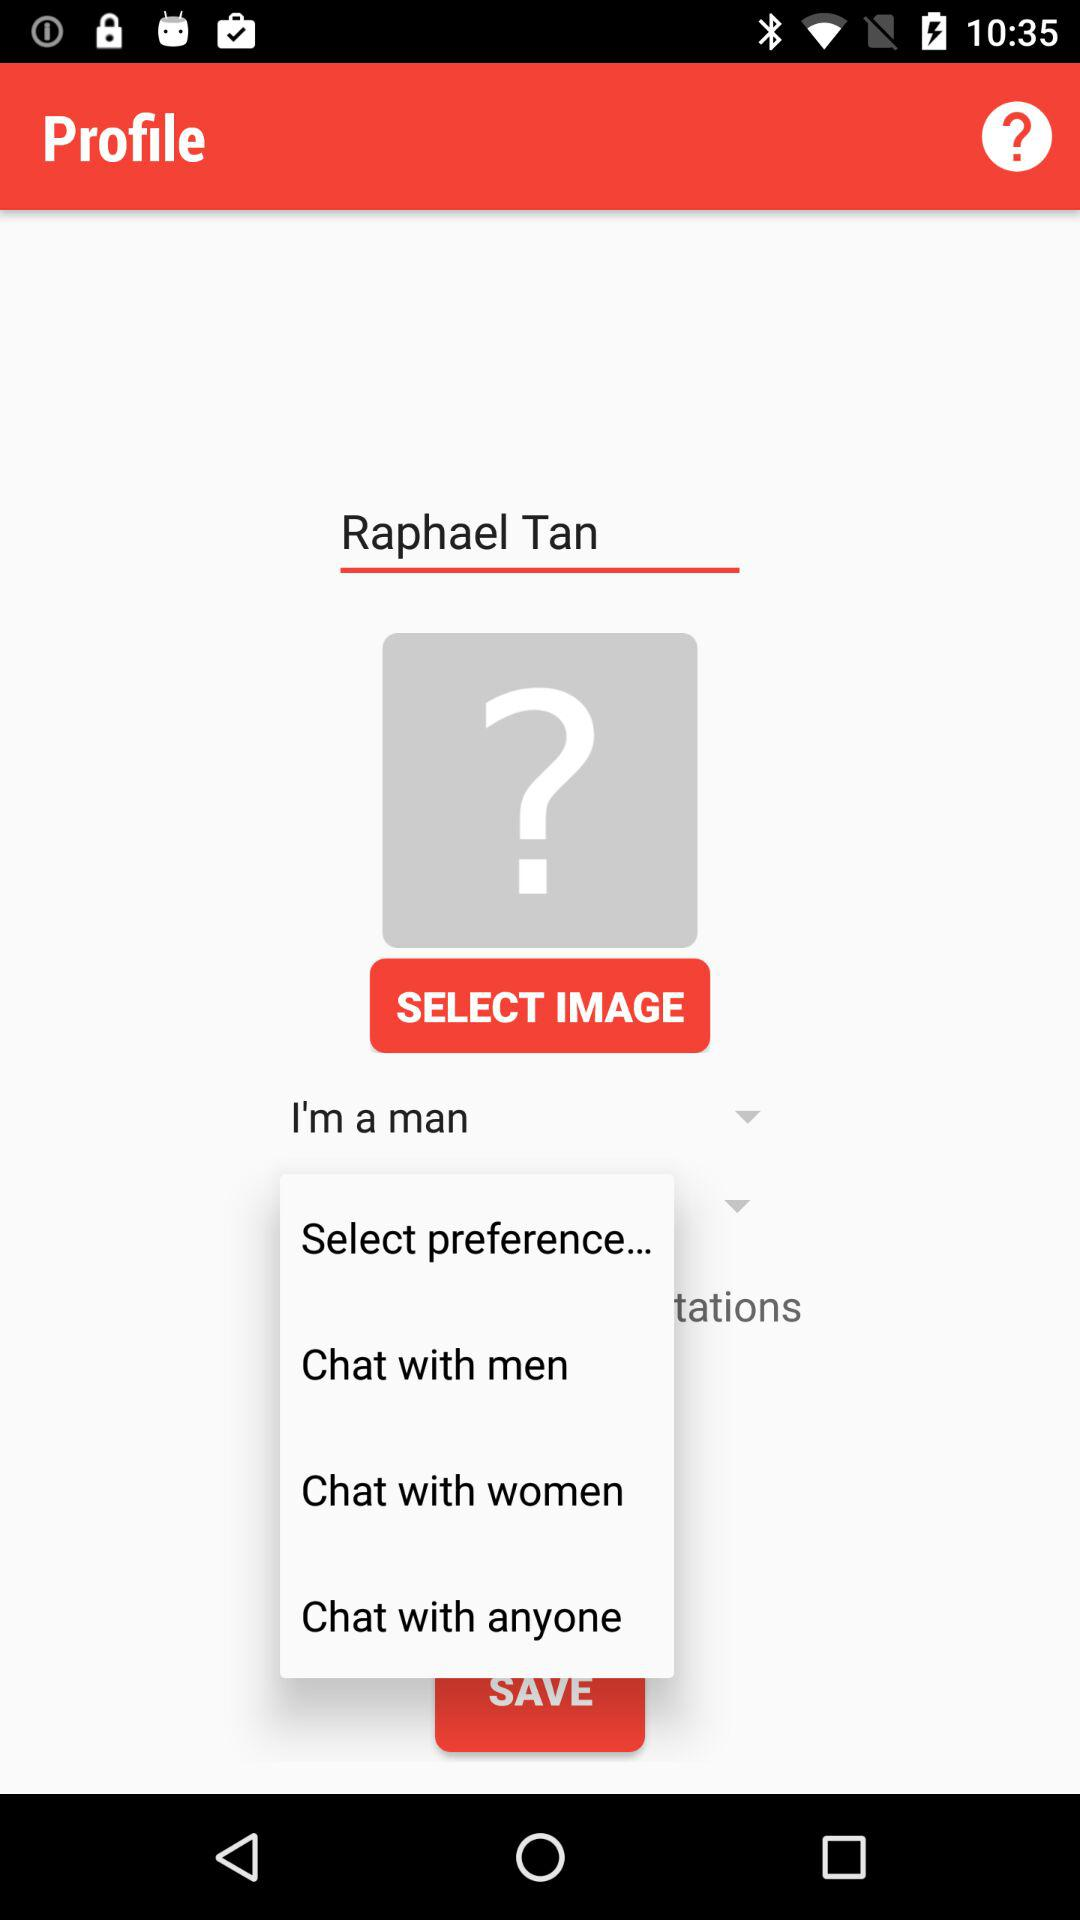How many more chat options are there than gender options?
Answer the question using a single word or phrase. 2 